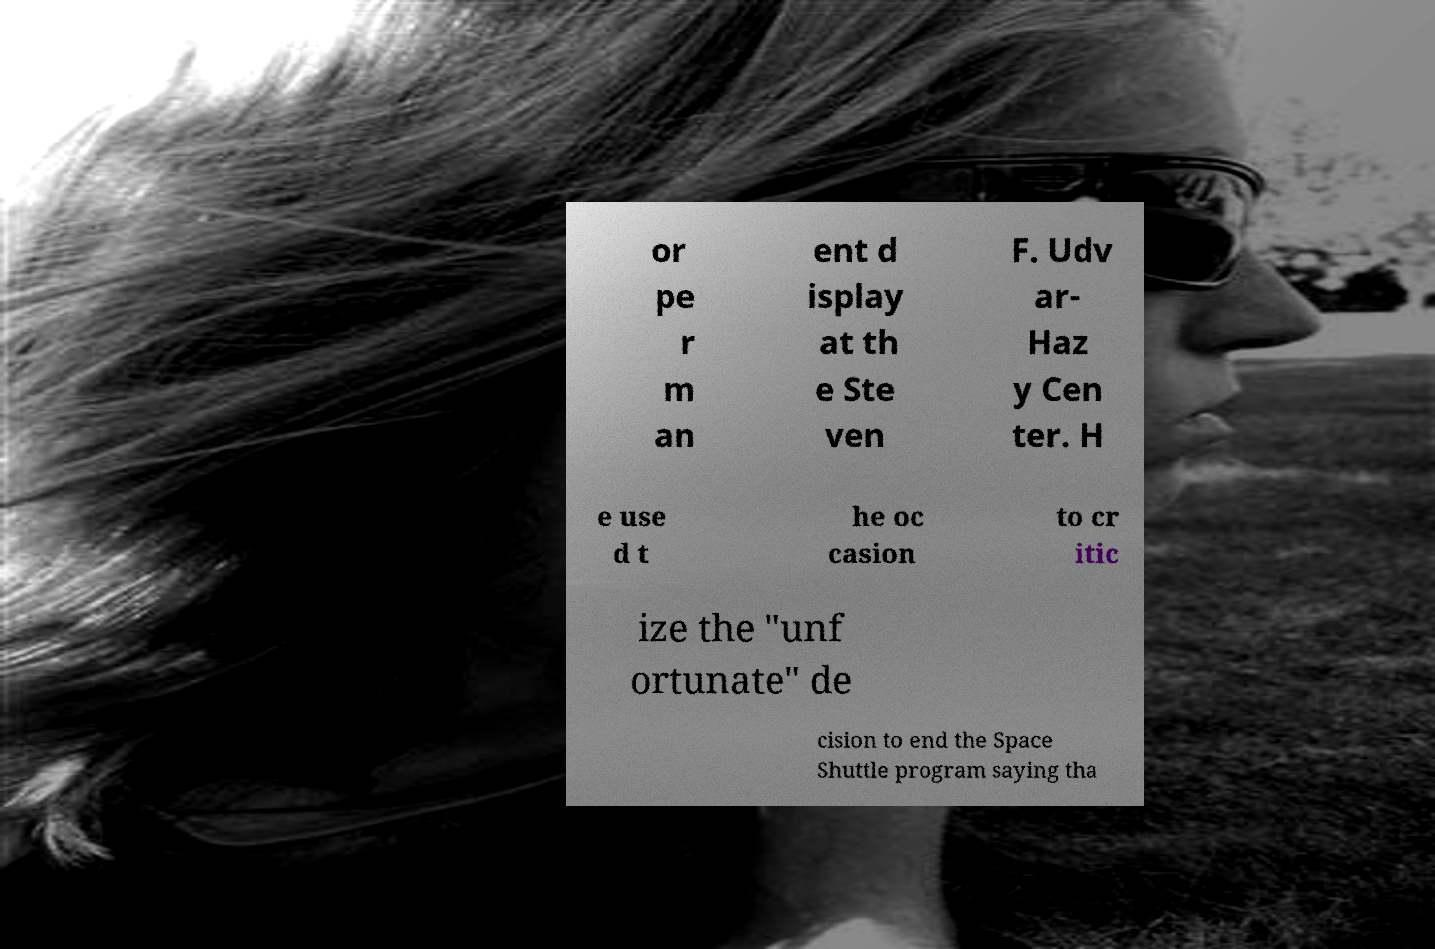Please identify and transcribe the text found in this image. or pe r m an ent d isplay at th e Ste ven F. Udv ar- Haz y Cen ter. H e use d t he oc casion to cr itic ize the "unf ortunate" de cision to end the Space Shuttle program saying tha 